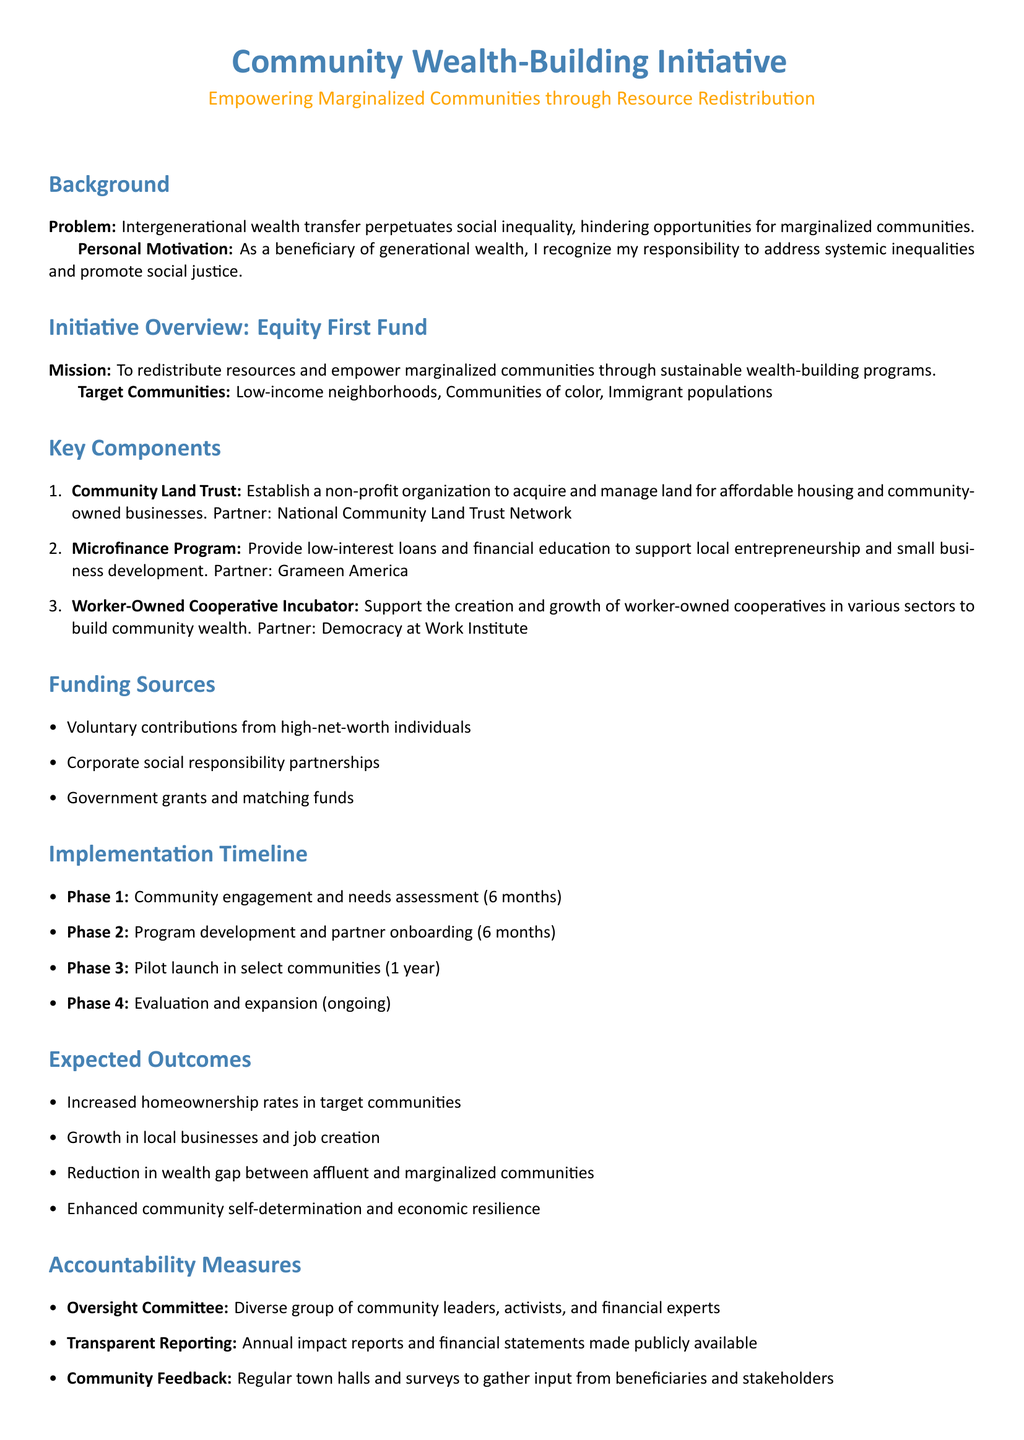What is the mission of the initiative? The mission is to redistribute resources and empower marginalized communities through sustainable wealth-building programs.
Answer: To redistribute resources and empower marginalized communities through sustainable wealth-building programs What are the target communities? The target communities include low-income neighborhoods, communities of color, and immigrant populations.
Answer: Low-income neighborhoods, communities of color, immigrant populations How many phases are in the implementation timeline? The document outlines four phases in the implementation timeline.
Answer: Four phases Who is the partner for the Community Land Trust? The partner mentioned for the Community Land Trust is the National Community Land Trust Network.
Answer: National Community Land Trust Network What is the expected outcome related to homeownership rates? One expected outcome is increased homeownership rates in target communities.
Answer: Increased homeownership rates in target communities What type of loans will the Microfinance Program provide? The Microfinance Program will provide low-interest loans to support local entrepreneurship and small business development.
Answer: Low-interest loans How will accountability be ensured in the initiative? Accountability will be ensured through an Oversight Committee, transparent reporting, and community feedback.
Answer: Oversight Committee, transparent reporting, community feedback What is the funding source involving high-net-worth individuals? Funding sources include voluntary contributions from high-net-worth individuals.
Answer: Voluntary contributions from high-net-worth individuals During which phase will the pilot launch occur? The pilot launch will occur during Phase 3.
Answer: Phase 3 